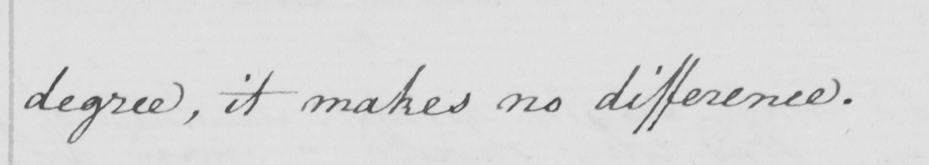Can you read and transcribe this handwriting? degree , it makes no difference . 